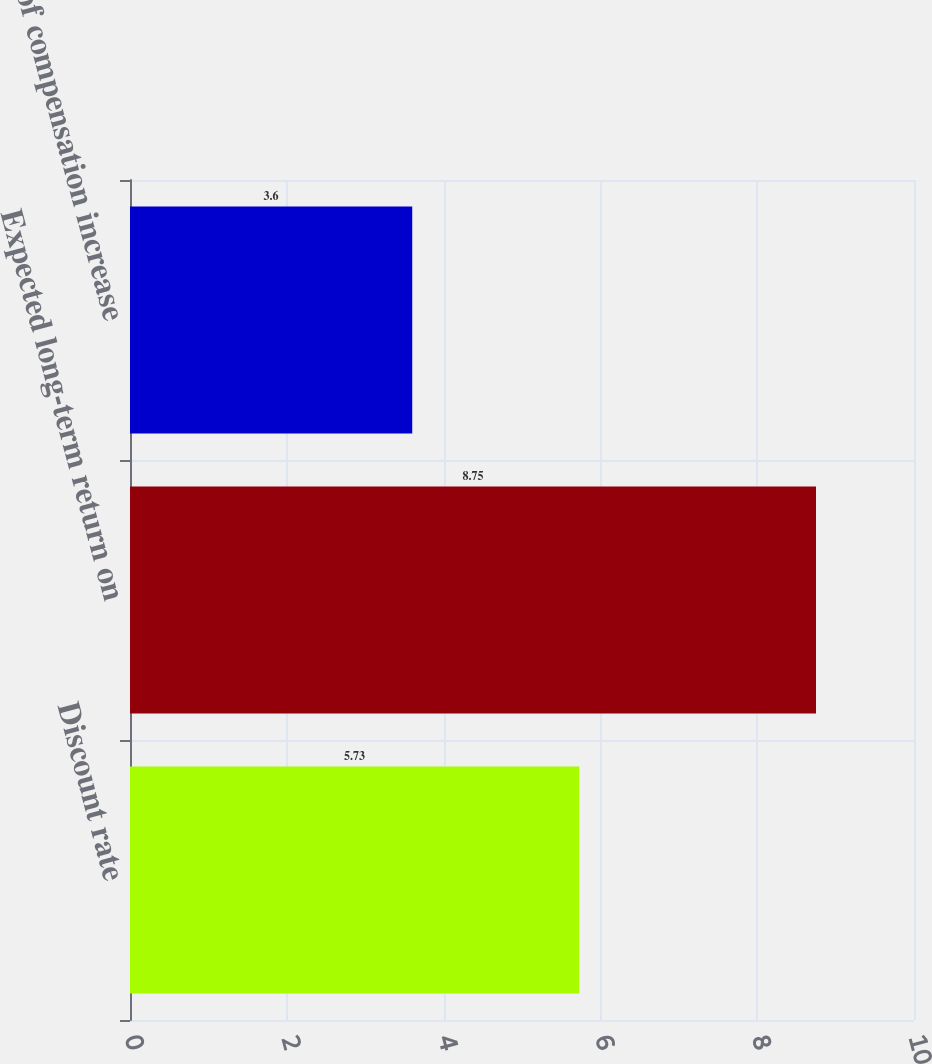Convert chart. <chart><loc_0><loc_0><loc_500><loc_500><bar_chart><fcel>Discount rate<fcel>Expected long-term return on<fcel>Rate of compensation increase<nl><fcel>5.73<fcel>8.75<fcel>3.6<nl></chart> 